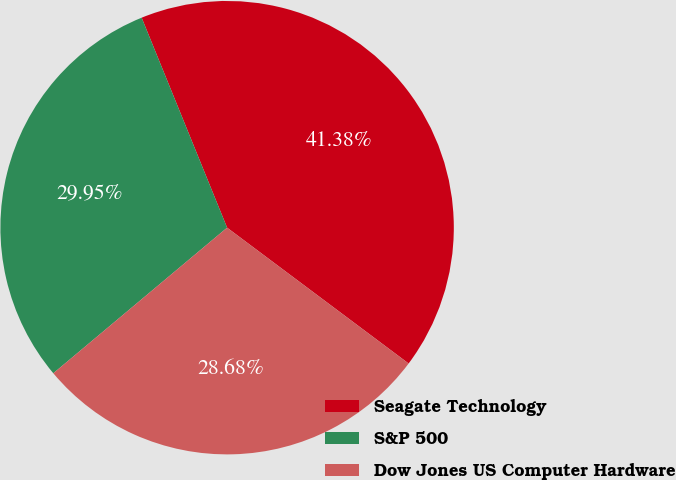Convert chart. <chart><loc_0><loc_0><loc_500><loc_500><pie_chart><fcel>Seagate Technology<fcel>S&P 500<fcel>Dow Jones US Computer Hardware<nl><fcel>41.38%<fcel>29.95%<fcel>28.68%<nl></chart> 